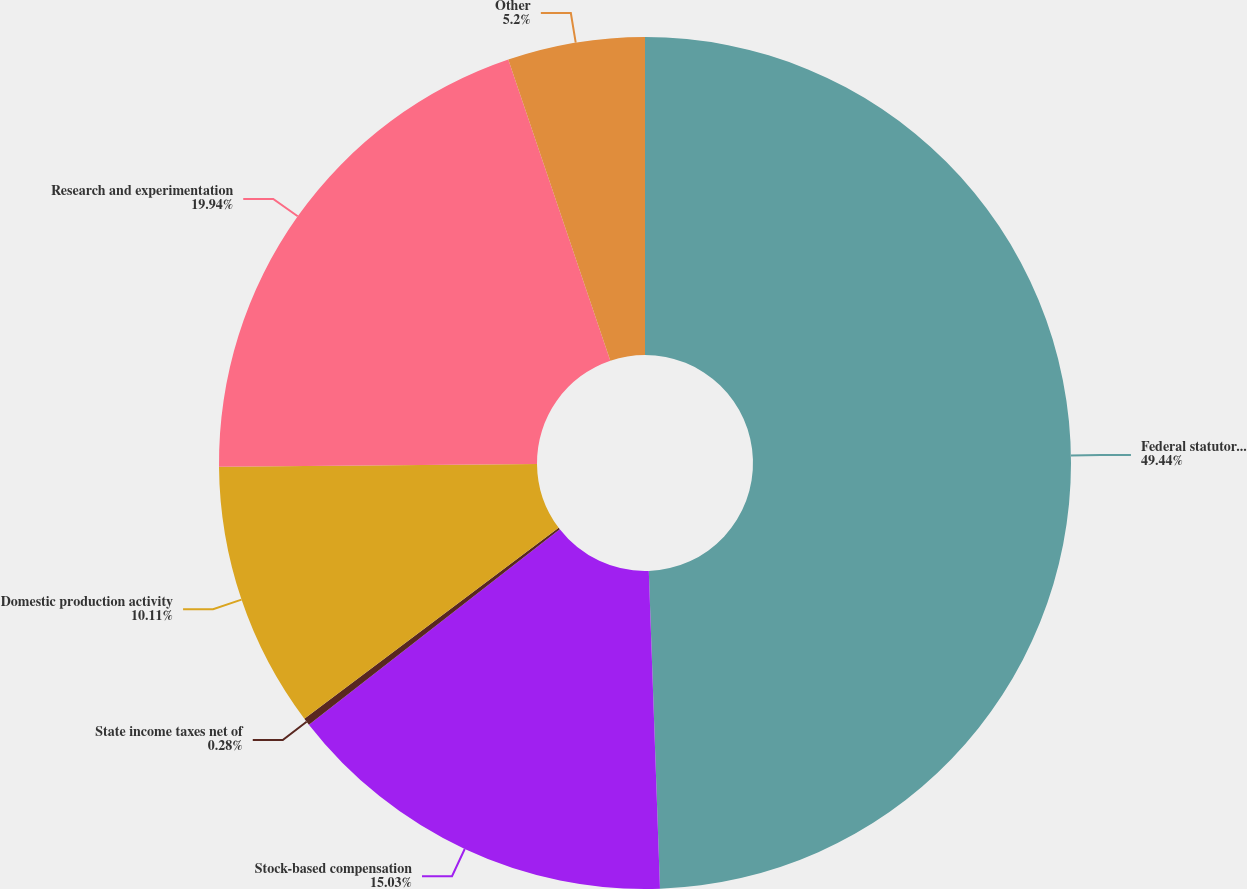<chart> <loc_0><loc_0><loc_500><loc_500><pie_chart><fcel>Federal statutory tax rate<fcel>Stock-based compensation<fcel>State income taxes net of<fcel>Domestic production activity<fcel>Research and experimentation<fcel>Other<nl><fcel>49.44%<fcel>15.03%<fcel>0.28%<fcel>10.11%<fcel>19.94%<fcel>5.2%<nl></chart> 